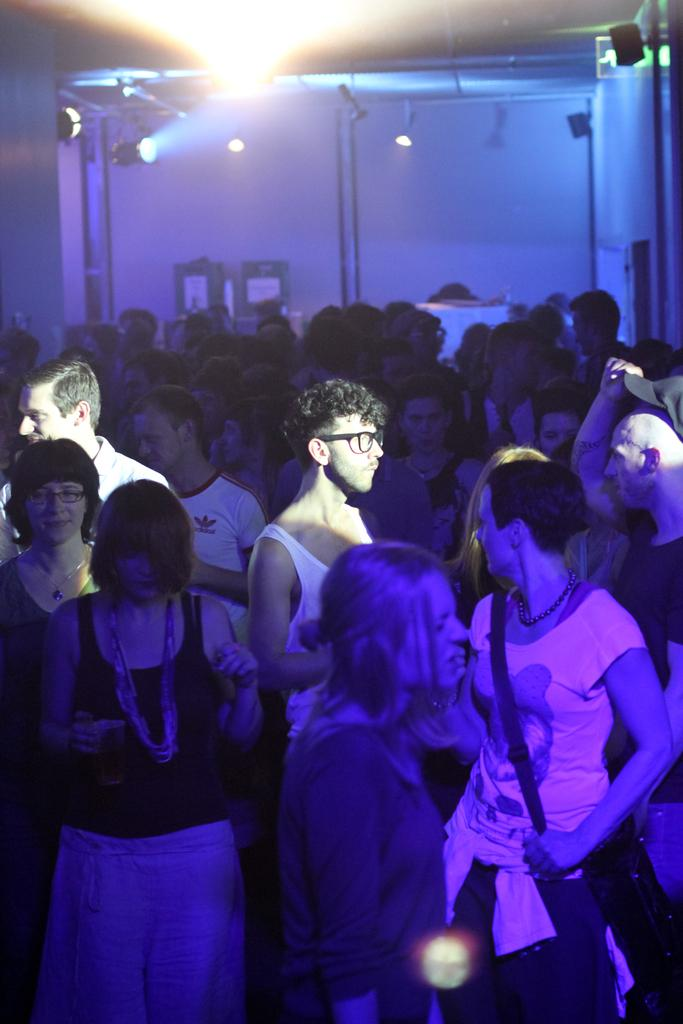Who or what can be seen in the image? There are people in the image. What is visible in the background of the image? There is a wall and focusing lights in the background of the image. Are there any other objects or elements in the background? Yes, there are objects in the background of the image. What type of farm animals can be seen in the image? There are no farm animals present in the image. What kind of plate is being used by the people in the image? There is no plate visible in the image. 